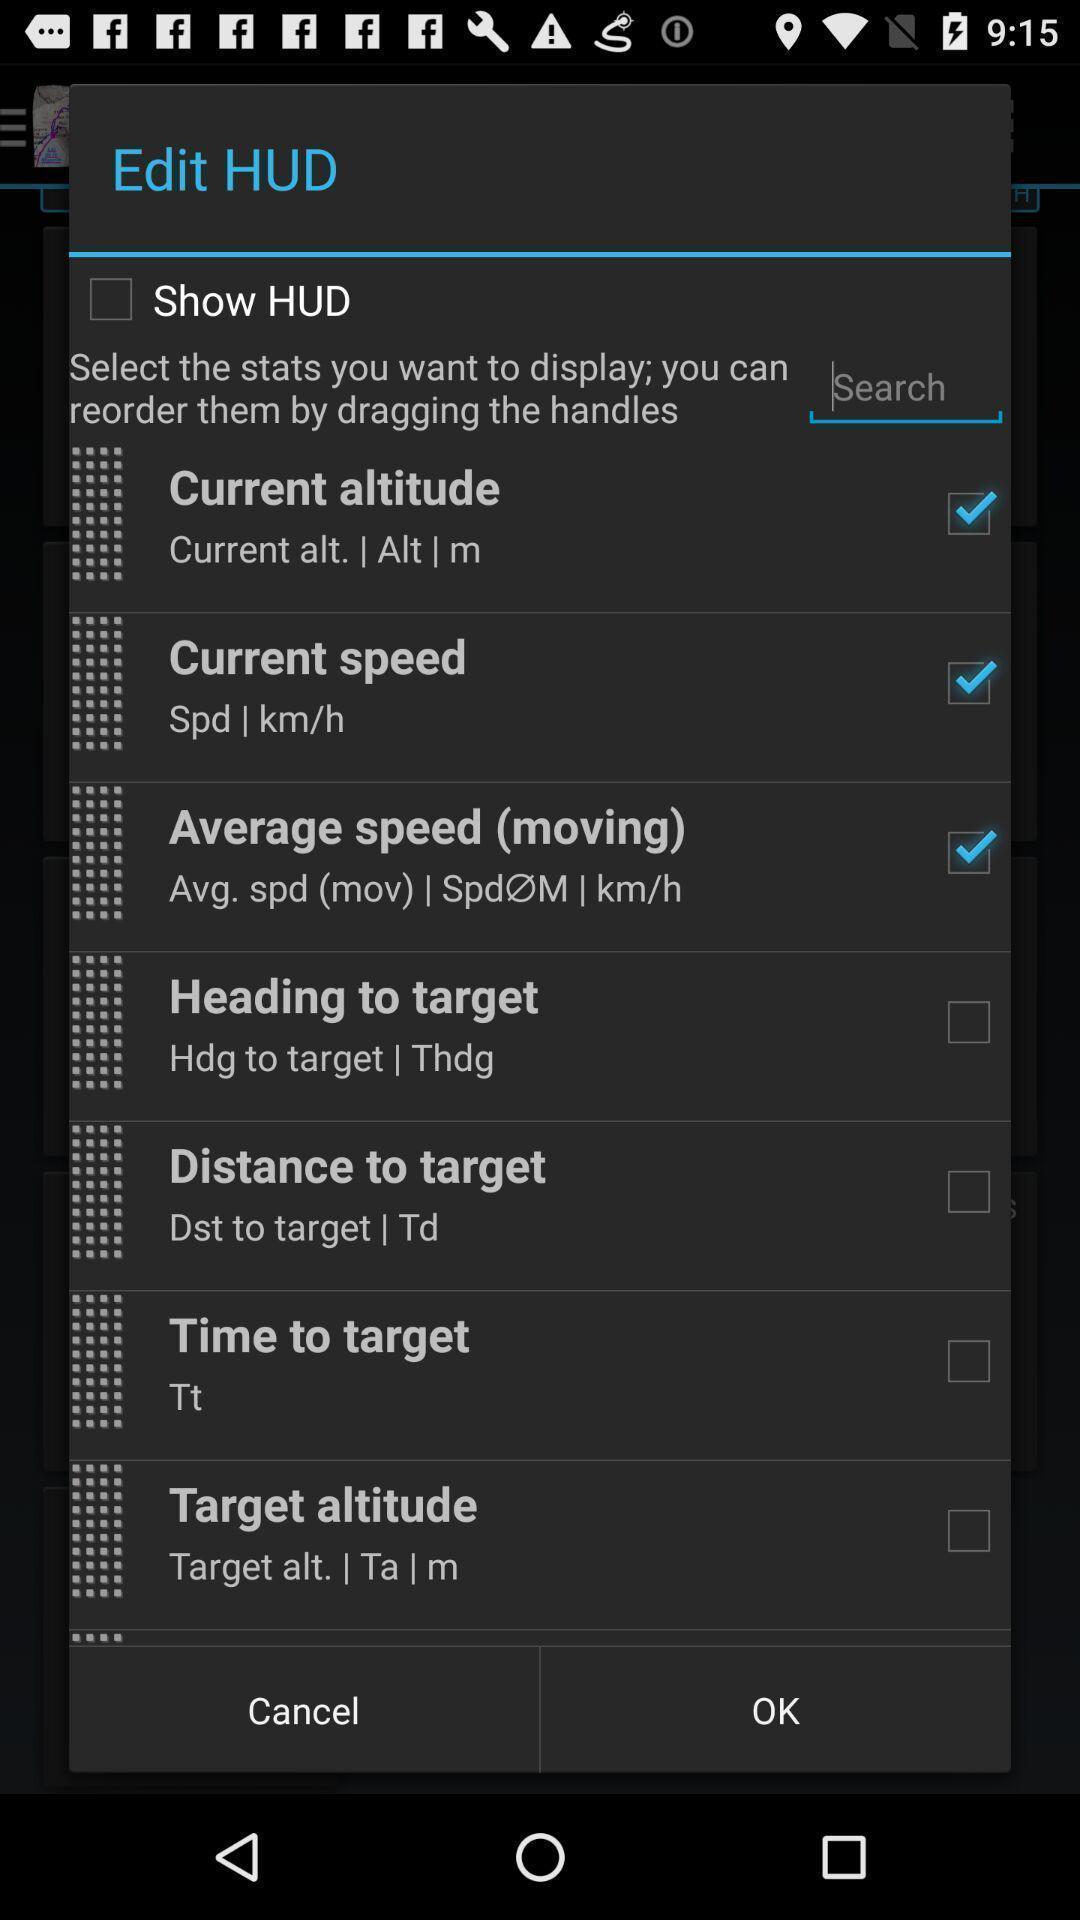Give me a summary of this screen capture. Screen displaying list of edit options. 